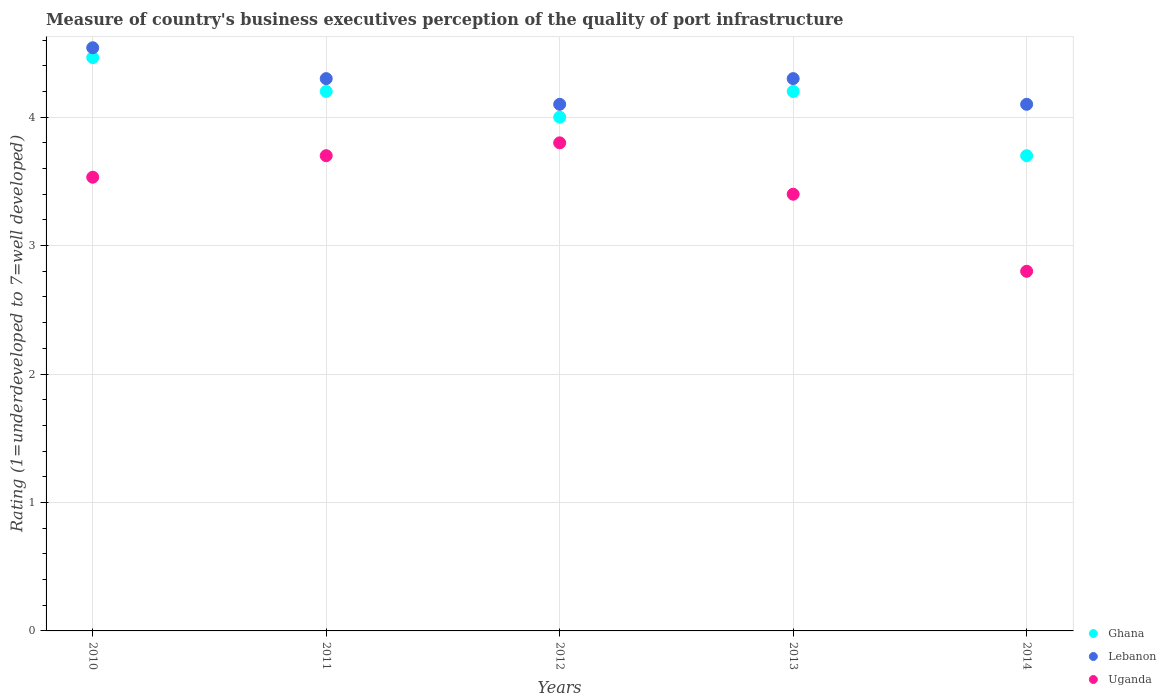Is the number of dotlines equal to the number of legend labels?
Your answer should be compact. Yes. Across all years, what is the maximum ratings of the quality of port infrastructure in Ghana?
Your response must be concise. 4.46. Across all years, what is the minimum ratings of the quality of port infrastructure in Uganda?
Your response must be concise. 2.8. In which year was the ratings of the quality of port infrastructure in Uganda minimum?
Offer a terse response. 2014. What is the total ratings of the quality of port infrastructure in Uganda in the graph?
Your response must be concise. 17.23. What is the difference between the ratings of the quality of port infrastructure in Uganda in 2011 and that in 2013?
Ensure brevity in your answer.  0.3. What is the difference between the ratings of the quality of port infrastructure in Uganda in 2011 and the ratings of the quality of port infrastructure in Lebanon in 2010?
Keep it short and to the point. -0.84. What is the average ratings of the quality of port infrastructure in Uganda per year?
Your answer should be compact. 3.45. In the year 2013, what is the difference between the ratings of the quality of port infrastructure in Uganda and ratings of the quality of port infrastructure in Ghana?
Ensure brevity in your answer.  -0.8. What is the ratio of the ratings of the quality of port infrastructure in Uganda in 2010 to that in 2014?
Keep it short and to the point. 1.26. Is the difference between the ratings of the quality of port infrastructure in Uganda in 2012 and 2014 greater than the difference between the ratings of the quality of port infrastructure in Ghana in 2012 and 2014?
Keep it short and to the point. Yes. What is the difference between the highest and the second highest ratings of the quality of port infrastructure in Uganda?
Your answer should be compact. 0.1. What is the difference between the highest and the lowest ratings of the quality of port infrastructure in Lebanon?
Your answer should be compact. 0.44. Is the sum of the ratings of the quality of port infrastructure in Ghana in 2011 and 2012 greater than the maximum ratings of the quality of port infrastructure in Uganda across all years?
Your answer should be compact. Yes. Is the ratings of the quality of port infrastructure in Ghana strictly less than the ratings of the quality of port infrastructure in Lebanon over the years?
Give a very brief answer. Yes. How many dotlines are there?
Offer a terse response. 3. How many years are there in the graph?
Provide a short and direct response. 5. Are the values on the major ticks of Y-axis written in scientific E-notation?
Make the answer very short. No. Does the graph contain grids?
Offer a very short reply. Yes. How many legend labels are there?
Give a very brief answer. 3. What is the title of the graph?
Ensure brevity in your answer.  Measure of country's business executives perception of the quality of port infrastructure. Does "Moldova" appear as one of the legend labels in the graph?
Your answer should be very brief. No. What is the label or title of the X-axis?
Give a very brief answer. Years. What is the label or title of the Y-axis?
Give a very brief answer. Rating (1=underdeveloped to 7=well developed). What is the Rating (1=underdeveloped to 7=well developed) in Ghana in 2010?
Offer a terse response. 4.46. What is the Rating (1=underdeveloped to 7=well developed) of Lebanon in 2010?
Provide a short and direct response. 4.54. What is the Rating (1=underdeveloped to 7=well developed) in Uganda in 2010?
Your response must be concise. 3.53. What is the Rating (1=underdeveloped to 7=well developed) of Lebanon in 2011?
Offer a terse response. 4.3. What is the Rating (1=underdeveloped to 7=well developed) of Uganda in 2011?
Provide a short and direct response. 3.7. What is the Rating (1=underdeveloped to 7=well developed) of Uganda in 2013?
Your answer should be very brief. 3.4. What is the Rating (1=underdeveloped to 7=well developed) in Uganda in 2014?
Your response must be concise. 2.8. Across all years, what is the maximum Rating (1=underdeveloped to 7=well developed) of Ghana?
Provide a succinct answer. 4.46. Across all years, what is the maximum Rating (1=underdeveloped to 7=well developed) of Lebanon?
Your response must be concise. 4.54. What is the total Rating (1=underdeveloped to 7=well developed) of Ghana in the graph?
Give a very brief answer. 20.56. What is the total Rating (1=underdeveloped to 7=well developed) in Lebanon in the graph?
Your answer should be very brief. 21.34. What is the total Rating (1=underdeveloped to 7=well developed) of Uganda in the graph?
Give a very brief answer. 17.23. What is the difference between the Rating (1=underdeveloped to 7=well developed) in Ghana in 2010 and that in 2011?
Provide a succinct answer. 0.26. What is the difference between the Rating (1=underdeveloped to 7=well developed) in Lebanon in 2010 and that in 2011?
Your answer should be compact. 0.24. What is the difference between the Rating (1=underdeveloped to 7=well developed) in Uganda in 2010 and that in 2011?
Your response must be concise. -0.17. What is the difference between the Rating (1=underdeveloped to 7=well developed) of Ghana in 2010 and that in 2012?
Offer a terse response. 0.46. What is the difference between the Rating (1=underdeveloped to 7=well developed) in Lebanon in 2010 and that in 2012?
Provide a succinct answer. 0.44. What is the difference between the Rating (1=underdeveloped to 7=well developed) of Uganda in 2010 and that in 2012?
Provide a short and direct response. -0.27. What is the difference between the Rating (1=underdeveloped to 7=well developed) of Ghana in 2010 and that in 2013?
Keep it short and to the point. 0.26. What is the difference between the Rating (1=underdeveloped to 7=well developed) in Lebanon in 2010 and that in 2013?
Your answer should be compact. 0.24. What is the difference between the Rating (1=underdeveloped to 7=well developed) in Uganda in 2010 and that in 2013?
Give a very brief answer. 0.13. What is the difference between the Rating (1=underdeveloped to 7=well developed) of Ghana in 2010 and that in 2014?
Offer a very short reply. 0.76. What is the difference between the Rating (1=underdeveloped to 7=well developed) of Lebanon in 2010 and that in 2014?
Give a very brief answer. 0.44. What is the difference between the Rating (1=underdeveloped to 7=well developed) of Uganda in 2010 and that in 2014?
Give a very brief answer. 0.73. What is the difference between the Rating (1=underdeveloped to 7=well developed) of Ghana in 2011 and that in 2012?
Make the answer very short. 0.2. What is the difference between the Rating (1=underdeveloped to 7=well developed) in Ghana in 2011 and that in 2013?
Provide a short and direct response. 0. What is the difference between the Rating (1=underdeveloped to 7=well developed) in Lebanon in 2011 and that in 2013?
Ensure brevity in your answer.  0. What is the difference between the Rating (1=underdeveloped to 7=well developed) of Uganda in 2011 and that in 2013?
Provide a succinct answer. 0.3. What is the difference between the Rating (1=underdeveloped to 7=well developed) of Lebanon in 2011 and that in 2014?
Give a very brief answer. 0.2. What is the difference between the Rating (1=underdeveloped to 7=well developed) in Ghana in 2012 and that in 2013?
Ensure brevity in your answer.  -0.2. What is the difference between the Rating (1=underdeveloped to 7=well developed) in Uganda in 2012 and that in 2013?
Give a very brief answer. 0.4. What is the difference between the Rating (1=underdeveloped to 7=well developed) of Ghana in 2012 and that in 2014?
Make the answer very short. 0.3. What is the difference between the Rating (1=underdeveloped to 7=well developed) of Lebanon in 2012 and that in 2014?
Keep it short and to the point. 0. What is the difference between the Rating (1=underdeveloped to 7=well developed) of Uganda in 2012 and that in 2014?
Keep it short and to the point. 1. What is the difference between the Rating (1=underdeveloped to 7=well developed) in Uganda in 2013 and that in 2014?
Your answer should be very brief. 0.6. What is the difference between the Rating (1=underdeveloped to 7=well developed) in Ghana in 2010 and the Rating (1=underdeveloped to 7=well developed) in Lebanon in 2011?
Keep it short and to the point. 0.16. What is the difference between the Rating (1=underdeveloped to 7=well developed) in Ghana in 2010 and the Rating (1=underdeveloped to 7=well developed) in Uganda in 2011?
Offer a terse response. 0.76. What is the difference between the Rating (1=underdeveloped to 7=well developed) in Lebanon in 2010 and the Rating (1=underdeveloped to 7=well developed) in Uganda in 2011?
Your answer should be very brief. 0.84. What is the difference between the Rating (1=underdeveloped to 7=well developed) in Ghana in 2010 and the Rating (1=underdeveloped to 7=well developed) in Lebanon in 2012?
Offer a terse response. 0.36. What is the difference between the Rating (1=underdeveloped to 7=well developed) in Ghana in 2010 and the Rating (1=underdeveloped to 7=well developed) in Uganda in 2012?
Offer a very short reply. 0.66. What is the difference between the Rating (1=underdeveloped to 7=well developed) in Lebanon in 2010 and the Rating (1=underdeveloped to 7=well developed) in Uganda in 2012?
Offer a very short reply. 0.74. What is the difference between the Rating (1=underdeveloped to 7=well developed) of Ghana in 2010 and the Rating (1=underdeveloped to 7=well developed) of Lebanon in 2013?
Ensure brevity in your answer.  0.16. What is the difference between the Rating (1=underdeveloped to 7=well developed) of Ghana in 2010 and the Rating (1=underdeveloped to 7=well developed) of Uganda in 2013?
Ensure brevity in your answer.  1.06. What is the difference between the Rating (1=underdeveloped to 7=well developed) of Lebanon in 2010 and the Rating (1=underdeveloped to 7=well developed) of Uganda in 2013?
Your answer should be very brief. 1.14. What is the difference between the Rating (1=underdeveloped to 7=well developed) in Ghana in 2010 and the Rating (1=underdeveloped to 7=well developed) in Lebanon in 2014?
Make the answer very short. 0.36. What is the difference between the Rating (1=underdeveloped to 7=well developed) of Ghana in 2010 and the Rating (1=underdeveloped to 7=well developed) of Uganda in 2014?
Give a very brief answer. 1.66. What is the difference between the Rating (1=underdeveloped to 7=well developed) of Lebanon in 2010 and the Rating (1=underdeveloped to 7=well developed) of Uganda in 2014?
Ensure brevity in your answer.  1.74. What is the difference between the Rating (1=underdeveloped to 7=well developed) of Ghana in 2011 and the Rating (1=underdeveloped to 7=well developed) of Lebanon in 2014?
Keep it short and to the point. 0.1. What is the difference between the Rating (1=underdeveloped to 7=well developed) of Ghana in 2011 and the Rating (1=underdeveloped to 7=well developed) of Uganda in 2014?
Offer a terse response. 1.4. What is the difference between the Rating (1=underdeveloped to 7=well developed) of Lebanon in 2011 and the Rating (1=underdeveloped to 7=well developed) of Uganda in 2014?
Your answer should be very brief. 1.5. What is the difference between the Rating (1=underdeveloped to 7=well developed) in Ghana in 2012 and the Rating (1=underdeveloped to 7=well developed) in Uganda in 2013?
Your answer should be compact. 0.6. What is the difference between the Rating (1=underdeveloped to 7=well developed) of Lebanon in 2012 and the Rating (1=underdeveloped to 7=well developed) of Uganda in 2013?
Offer a terse response. 0.7. What is the difference between the Rating (1=underdeveloped to 7=well developed) of Ghana in 2012 and the Rating (1=underdeveloped to 7=well developed) of Lebanon in 2014?
Provide a succinct answer. -0.1. What is the difference between the Rating (1=underdeveloped to 7=well developed) of Ghana in 2012 and the Rating (1=underdeveloped to 7=well developed) of Uganda in 2014?
Give a very brief answer. 1.2. What is the difference between the Rating (1=underdeveloped to 7=well developed) in Lebanon in 2012 and the Rating (1=underdeveloped to 7=well developed) in Uganda in 2014?
Your response must be concise. 1.3. What is the difference between the Rating (1=underdeveloped to 7=well developed) in Ghana in 2013 and the Rating (1=underdeveloped to 7=well developed) in Lebanon in 2014?
Provide a short and direct response. 0.1. What is the difference between the Rating (1=underdeveloped to 7=well developed) of Ghana in 2013 and the Rating (1=underdeveloped to 7=well developed) of Uganda in 2014?
Provide a succinct answer. 1.4. What is the average Rating (1=underdeveloped to 7=well developed) of Ghana per year?
Offer a terse response. 4.11. What is the average Rating (1=underdeveloped to 7=well developed) of Lebanon per year?
Offer a terse response. 4.27. What is the average Rating (1=underdeveloped to 7=well developed) of Uganda per year?
Offer a very short reply. 3.45. In the year 2010, what is the difference between the Rating (1=underdeveloped to 7=well developed) in Ghana and Rating (1=underdeveloped to 7=well developed) in Lebanon?
Your answer should be compact. -0.08. In the year 2010, what is the difference between the Rating (1=underdeveloped to 7=well developed) of Ghana and Rating (1=underdeveloped to 7=well developed) of Uganda?
Offer a terse response. 0.93. In the year 2010, what is the difference between the Rating (1=underdeveloped to 7=well developed) in Lebanon and Rating (1=underdeveloped to 7=well developed) in Uganda?
Give a very brief answer. 1.01. In the year 2011, what is the difference between the Rating (1=underdeveloped to 7=well developed) of Ghana and Rating (1=underdeveloped to 7=well developed) of Lebanon?
Make the answer very short. -0.1. In the year 2011, what is the difference between the Rating (1=underdeveloped to 7=well developed) in Lebanon and Rating (1=underdeveloped to 7=well developed) in Uganda?
Your answer should be very brief. 0.6. In the year 2012, what is the difference between the Rating (1=underdeveloped to 7=well developed) in Lebanon and Rating (1=underdeveloped to 7=well developed) in Uganda?
Keep it short and to the point. 0.3. In the year 2013, what is the difference between the Rating (1=underdeveloped to 7=well developed) of Lebanon and Rating (1=underdeveloped to 7=well developed) of Uganda?
Offer a terse response. 0.9. In the year 2014, what is the difference between the Rating (1=underdeveloped to 7=well developed) in Ghana and Rating (1=underdeveloped to 7=well developed) in Lebanon?
Offer a terse response. -0.4. In the year 2014, what is the difference between the Rating (1=underdeveloped to 7=well developed) in Lebanon and Rating (1=underdeveloped to 7=well developed) in Uganda?
Provide a succinct answer. 1.3. What is the ratio of the Rating (1=underdeveloped to 7=well developed) of Ghana in 2010 to that in 2011?
Provide a short and direct response. 1.06. What is the ratio of the Rating (1=underdeveloped to 7=well developed) in Lebanon in 2010 to that in 2011?
Give a very brief answer. 1.06. What is the ratio of the Rating (1=underdeveloped to 7=well developed) in Uganda in 2010 to that in 2011?
Provide a short and direct response. 0.95. What is the ratio of the Rating (1=underdeveloped to 7=well developed) of Ghana in 2010 to that in 2012?
Ensure brevity in your answer.  1.12. What is the ratio of the Rating (1=underdeveloped to 7=well developed) of Lebanon in 2010 to that in 2012?
Give a very brief answer. 1.11. What is the ratio of the Rating (1=underdeveloped to 7=well developed) of Uganda in 2010 to that in 2012?
Your response must be concise. 0.93. What is the ratio of the Rating (1=underdeveloped to 7=well developed) in Ghana in 2010 to that in 2013?
Your answer should be very brief. 1.06. What is the ratio of the Rating (1=underdeveloped to 7=well developed) of Lebanon in 2010 to that in 2013?
Give a very brief answer. 1.06. What is the ratio of the Rating (1=underdeveloped to 7=well developed) of Uganda in 2010 to that in 2013?
Provide a succinct answer. 1.04. What is the ratio of the Rating (1=underdeveloped to 7=well developed) in Ghana in 2010 to that in 2014?
Your answer should be very brief. 1.21. What is the ratio of the Rating (1=underdeveloped to 7=well developed) in Lebanon in 2010 to that in 2014?
Offer a very short reply. 1.11. What is the ratio of the Rating (1=underdeveloped to 7=well developed) of Uganda in 2010 to that in 2014?
Your response must be concise. 1.26. What is the ratio of the Rating (1=underdeveloped to 7=well developed) in Ghana in 2011 to that in 2012?
Make the answer very short. 1.05. What is the ratio of the Rating (1=underdeveloped to 7=well developed) in Lebanon in 2011 to that in 2012?
Give a very brief answer. 1.05. What is the ratio of the Rating (1=underdeveloped to 7=well developed) of Uganda in 2011 to that in 2012?
Your response must be concise. 0.97. What is the ratio of the Rating (1=underdeveloped to 7=well developed) in Lebanon in 2011 to that in 2013?
Offer a very short reply. 1. What is the ratio of the Rating (1=underdeveloped to 7=well developed) of Uganda in 2011 to that in 2013?
Offer a very short reply. 1.09. What is the ratio of the Rating (1=underdeveloped to 7=well developed) of Ghana in 2011 to that in 2014?
Provide a succinct answer. 1.14. What is the ratio of the Rating (1=underdeveloped to 7=well developed) of Lebanon in 2011 to that in 2014?
Your answer should be compact. 1.05. What is the ratio of the Rating (1=underdeveloped to 7=well developed) in Uganda in 2011 to that in 2014?
Provide a succinct answer. 1.32. What is the ratio of the Rating (1=underdeveloped to 7=well developed) of Lebanon in 2012 to that in 2013?
Make the answer very short. 0.95. What is the ratio of the Rating (1=underdeveloped to 7=well developed) in Uganda in 2012 to that in 2013?
Offer a very short reply. 1.12. What is the ratio of the Rating (1=underdeveloped to 7=well developed) in Ghana in 2012 to that in 2014?
Offer a terse response. 1.08. What is the ratio of the Rating (1=underdeveloped to 7=well developed) in Uganda in 2012 to that in 2014?
Give a very brief answer. 1.36. What is the ratio of the Rating (1=underdeveloped to 7=well developed) in Ghana in 2013 to that in 2014?
Provide a succinct answer. 1.14. What is the ratio of the Rating (1=underdeveloped to 7=well developed) in Lebanon in 2013 to that in 2014?
Offer a terse response. 1.05. What is the ratio of the Rating (1=underdeveloped to 7=well developed) of Uganda in 2013 to that in 2014?
Your answer should be compact. 1.21. What is the difference between the highest and the second highest Rating (1=underdeveloped to 7=well developed) in Ghana?
Your response must be concise. 0.26. What is the difference between the highest and the second highest Rating (1=underdeveloped to 7=well developed) in Lebanon?
Offer a very short reply. 0.24. What is the difference between the highest and the lowest Rating (1=underdeveloped to 7=well developed) in Ghana?
Provide a short and direct response. 0.76. What is the difference between the highest and the lowest Rating (1=underdeveloped to 7=well developed) of Lebanon?
Your response must be concise. 0.44. 